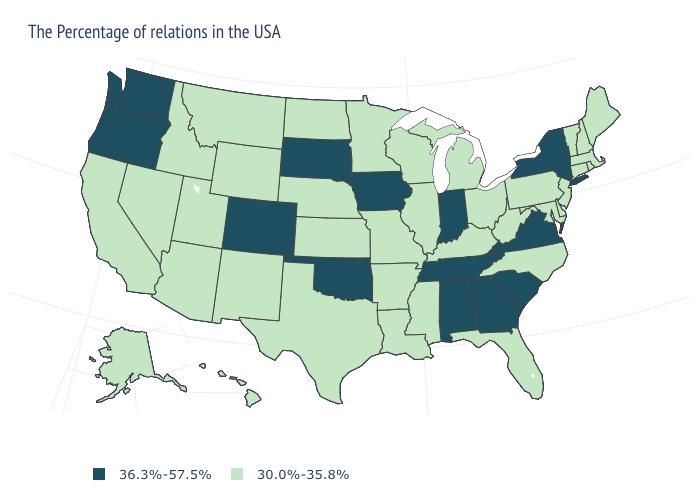What is the value of Virginia?
Give a very brief answer. 36.3%-57.5%. Does Alaska have a lower value than Georgia?
Keep it brief. Yes. Does California have the highest value in the West?
Answer briefly. No. Among the states that border West Virginia , does Virginia have the lowest value?
Give a very brief answer. No. Does Pennsylvania have a lower value than Alabama?
Write a very short answer. Yes. What is the value of Vermont?
Answer briefly. 30.0%-35.8%. What is the value of Kentucky?
Concise answer only. 30.0%-35.8%. Which states have the lowest value in the Northeast?
Answer briefly. Maine, Massachusetts, Rhode Island, New Hampshire, Vermont, Connecticut, New Jersey, Pennsylvania. Name the states that have a value in the range 36.3%-57.5%?
Short answer required. New York, Virginia, South Carolina, Georgia, Indiana, Alabama, Tennessee, Iowa, Oklahoma, South Dakota, Colorado, Washington, Oregon. What is the value of Tennessee?
Concise answer only. 36.3%-57.5%. What is the value of Mississippi?
Give a very brief answer. 30.0%-35.8%. Name the states that have a value in the range 36.3%-57.5%?
Be succinct. New York, Virginia, South Carolina, Georgia, Indiana, Alabama, Tennessee, Iowa, Oklahoma, South Dakota, Colorado, Washington, Oregon. Which states have the lowest value in the Northeast?
Give a very brief answer. Maine, Massachusetts, Rhode Island, New Hampshire, Vermont, Connecticut, New Jersey, Pennsylvania. Name the states that have a value in the range 30.0%-35.8%?
Be succinct. Maine, Massachusetts, Rhode Island, New Hampshire, Vermont, Connecticut, New Jersey, Delaware, Maryland, Pennsylvania, North Carolina, West Virginia, Ohio, Florida, Michigan, Kentucky, Wisconsin, Illinois, Mississippi, Louisiana, Missouri, Arkansas, Minnesota, Kansas, Nebraska, Texas, North Dakota, Wyoming, New Mexico, Utah, Montana, Arizona, Idaho, Nevada, California, Alaska, Hawaii. How many symbols are there in the legend?
Give a very brief answer. 2. 